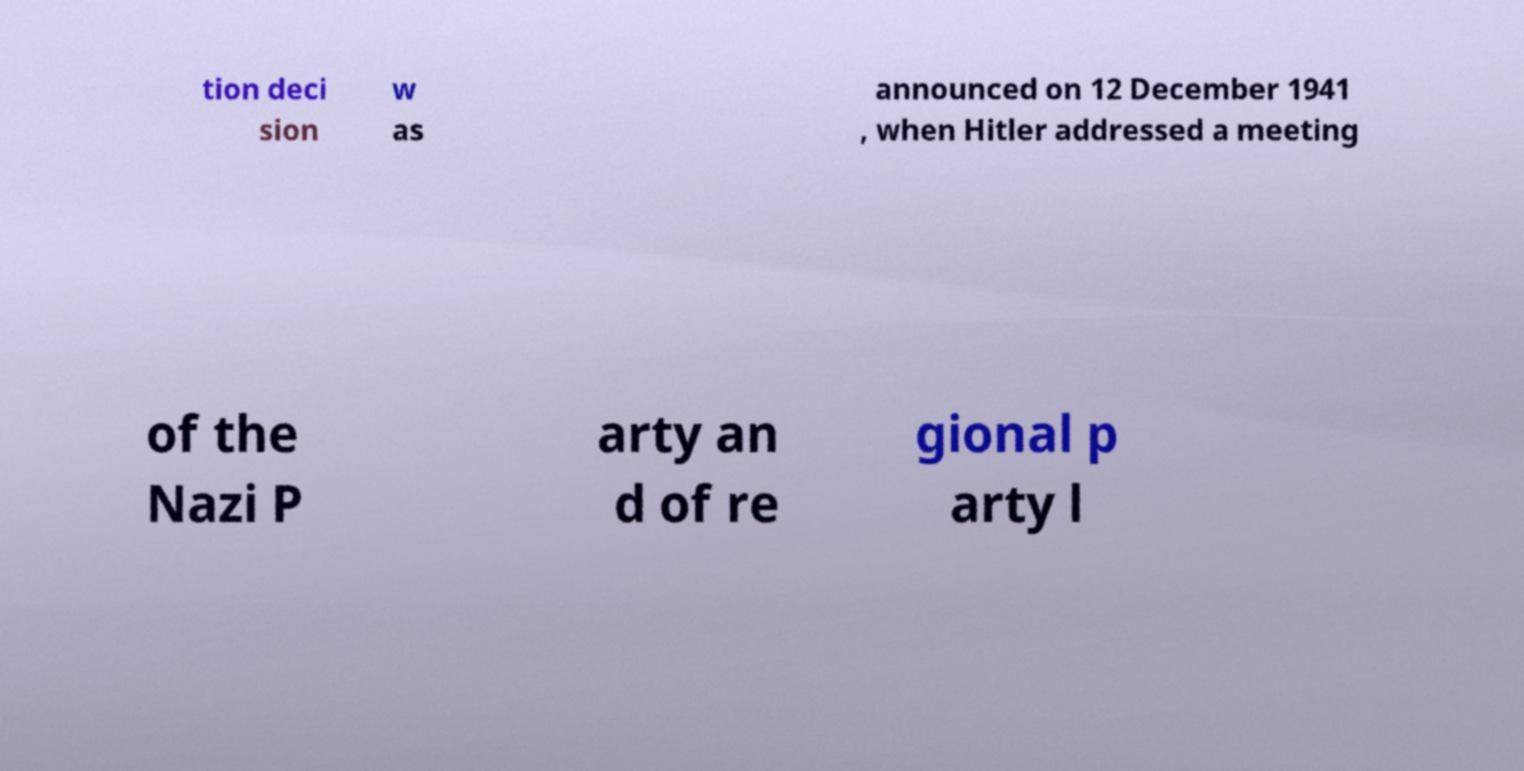Could you extract and type out the text from this image? tion deci sion w as announced on 12 December 1941 , when Hitler addressed a meeting of the Nazi P arty an d of re gional p arty l 